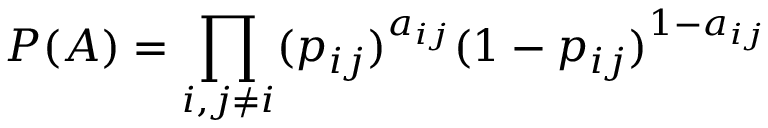<formula> <loc_0><loc_0><loc_500><loc_500>P ( A ) = \prod _ { i , j \neq i } ( p _ { i j } ) ^ { a _ { i j } } ( 1 - p _ { i j } ) ^ { 1 - a _ { i j } }</formula> 